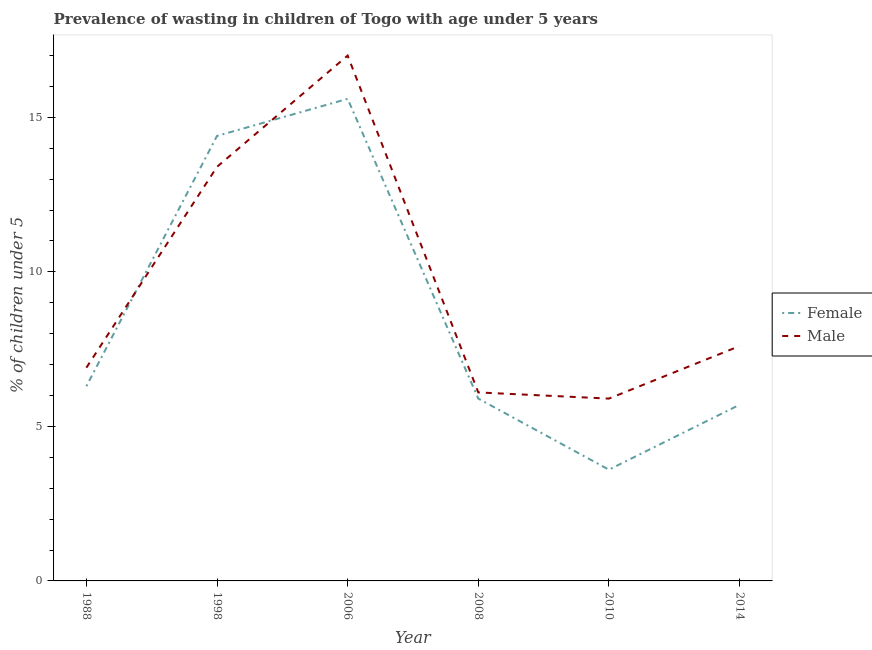How many different coloured lines are there?
Provide a short and direct response. 2. Is the number of lines equal to the number of legend labels?
Offer a very short reply. Yes. Across all years, what is the maximum percentage of undernourished male children?
Provide a succinct answer. 17. Across all years, what is the minimum percentage of undernourished male children?
Give a very brief answer. 5.9. In which year was the percentage of undernourished male children maximum?
Provide a short and direct response. 2006. What is the total percentage of undernourished female children in the graph?
Your response must be concise. 51.5. What is the difference between the percentage of undernourished female children in 1998 and that in 2010?
Provide a succinct answer. 10.8. What is the difference between the percentage of undernourished male children in 1998 and the percentage of undernourished female children in 2014?
Give a very brief answer. 7.7. What is the average percentage of undernourished female children per year?
Provide a short and direct response. 8.58. In the year 2010, what is the difference between the percentage of undernourished male children and percentage of undernourished female children?
Keep it short and to the point. 2.3. In how many years, is the percentage of undernourished male children greater than 12 %?
Your response must be concise. 2. What is the ratio of the percentage of undernourished male children in 2008 to that in 2010?
Give a very brief answer. 1.03. Is the difference between the percentage of undernourished female children in 1998 and 2010 greater than the difference between the percentage of undernourished male children in 1998 and 2010?
Make the answer very short. Yes. What is the difference between the highest and the second highest percentage of undernourished male children?
Your response must be concise. 3.6. What is the difference between the highest and the lowest percentage of undernourished female children?
Make the answer very short. 12. Is the percentage of undernourished male children strictly less than the percentage of undernourished female children over the years?
Provide a succinct answer. No. How many lines are there?
Your answer should be compact. 2. How many years are there in the graph?
Your answer should be very brief. 6. What is the difference between two consecutive major ticks on the Y-axis?
Offer a very short reply. 5. Are the values on the major ticks of Y-axis written in scientific E-notation?
Keep it short and to the point. No. Where does the legend appear in the graph?
Give a very brief answer. Center right. What is the title of the graph?
Keep it short and to the point. Prevalence of wasting in children of Togo with age under 5 years. What is the label or title of the X-axis?
Make the answer very short. Year. What is the label or title of the Y-axis?
Make the answer very short.  % of children under 5. What is the  % of children under 5 in Female in 1988?
Your response must be concise. 6.3. What is the  % of children under 5 in Male in 1988?
Keep it short and to the point. 6.9. What is the  % of children under 5 of Female in 1998?
Offer a very short reply. 14.4. What is the  % of children under 5 of Male in 1998?
Provide a succinct answer. 13.4. What is the  % of children under 5 of Female in 2006?
Keep it short and to the point. 15.6. What is the  % of children under 5 in Female in 2008?
Ensure brevity in your answer.  5.9. What is the  % of children under 5 of Male in 2008?
Offer a terse response. 6.1. What is the  % of children under 5 in Female in 2010?
Provide a succinct answer. 3.6. What is the  % of children under 5 of Male in 2010?
Provide a succinct answer. 5.9. What is the  % of children under 5 in Female in 2014?
Offer a terse response. 5.7. What is the  % of children under 5 in Male in 2014?
Your response must be concise. 7.6. Across all years, what is the maximum  % of children under 5 in Female?
Your response must be concise. 15.6. Across all years, what is the maximum  % of children under 5 in Male?
Give a very brief answer. 17. Across all years, what is the minimum  % of children under 5 in Female?
Make the answer very short. 3.6. Across all years, what is the minimum  % of children under 5 of Male?
Provide a succinct answer. 5.9. What is the total  % of children under 5 of Female in the graph?
Make the answer very short. 51.5. What is the total  % of children under 5 in Male in the graph?
Provide a succinct answer. 56.9. What is the difference between the  % of children under 5 of Male in 1988 and that in 1998?
Make the answer very short. -6.5. What is the difference between the  % of children under 5 of Male in 1988 and that in 2006?
Your answer should be very brief. -10.1. What is the difference between the  % of children under 5 in Female in 1988 and that in 2008?
Make the answer very short. 0.4. What is the difference between the  % of children under 5 in Male in 1988 and that in 2008?
Ensure brevity in your answer.  0.8. What is the difference between the  % of children under 5 of Female in 1988 and that in 2010?
Ensure brevity in your answer.  2.7. What is the difference between the  % of children under 5 in Male in 1988 and that in 2010?
Make the answer very short. 1. What is the difference between the  % of children under 5 of Female in 1988 and that in 2014?
Give a very brief answer. 0.6. What is the difference between the  % of children under 5 in Female in 1998 and that in 2006?
Offer a very short reply. -1.2. What is the difference between the  % of children under 5 of Male in 1998 and that in 2008?
Offer a terse response. 7.3. What is the difference between the  % of children under 5 in Male in 1998 and that in 2010?
Give a very brief answer. 7.5. What is the difference between the  % of children under 5 of Male in 1998 and that in 2014?
Make the answer very short. 5.8. What is the difference between the  % of children under 5 in Female in 2006 and that in 2008?
Your answer should be compact. 9.7. What is the difference between the  % of children under 5 in Female in 2006 and that in 2010?
Keep it short and to the point. 12. What is the difference between the  % of children under 5 in Female in 2006 and that in 2014?
Your answer should be compact. 9.9. What is the difference between the  % of children under 5 of Male in 2008 and that in 2010?
Keep it short and to the point. 0.2. What is the difference between the  % of children under 5 in Male in 2008 and that in 2014?
Your answer should be compact. -1.5. What is the difference between the  % of children under 5 of Female in 1988 and the  % of children under 5 of Male in 2008?
Provide a succinct answer. 0.2. What is the difference between the  % of children under 5 of Female in 1988 and the  % of children under 5 of Male in 2010?
Keep it short and to the point. 0.4. What is the difference between the  % of children under 5 of Female in 1988 and the  % of children under 5 of Male in 2014?
Offer a terse response. -1.3. What is the difference between the  % of children under 5 in Female in 1998 and the  % of children under 5 in Male in 2006?
Make the answer very short. -2.6. What is the difference between the  % of children under 5 of Female in 1998 and the  % of children under 5 of Male in 2010?
Provide a succinct answer. 8.5. What is the difference between the  % of children under 5 of Female in 1998 and the  % of children under 5 of Male in 2014?
Your answer should be very brief. 6.8. What is the difference between the  % of children under 5 of Female in 2006 and the  % of children under 5 of Male in 2014?
Make the answer very short. 8. What is the average  % of children under 5 of Female per year?
Offer a terse response. 8.58. What is the average  % of children under 5 of Male per year?
Your answer should be very brief. 9.48. In the year 1998, what is the difference between the  % of children under 5 in Female and  % of children under 5 in Male?
Make the answer very short. 1. In the year 2006, what is the difference between the  % of children under 5 of Female and  % of children under 5 of Male?
Make the answer very short. -1.4. In the year 2014, what is the difference between the  % of children under 5 in Female and  % of children under 5 in Male?
Keep it short and to the point. -1.9. What is the ratio of the  % of children under 5 in Female in 1988 to that in 1998?
Make the answer very short. 0.44. What is the ratio of the  % of children under 5 of Male in 1988 to that in 1998?
Keep it short and to the point. 0.51. What is the ratio of the  % of children under 5 of Female in 1988 to that in 2006?
Your answer should be very brief. 0.4. What is the ratio of the  % of children under 5 in Male in 1988 to that in 2006?
Ensure brevity in your answer.  0.41. What is the ratio of the  % of children under 5 in Female in 1988 to that in 2008?
Keep it short and to the point. 1.07. What is the ratio of the  % of children under 5 of Male in 1988 to that in 2008?
Your response must be concise. 1.13. What is the ratio of the  % of children under 5 of Male in 1988 to that in 2010?
Your answer should be compact. 1.17. What is the ratio of the  % of children under 5 of Female in 1988 to that in 2014?
Ensure brevity in your answer.  1.11. What is the ratio of the  % of children under 5 of Male in 1988 to that in 2014?
Your answer should be compact. 0.91. What is the ratio of the  % of children under 5 of Male in 1998 to that in 2006?
Your answer should be compact. 0.79. What is the ratio of the  % of children under 5 in Female in 1998 to that in 2008?
Your answer should be very brief. 2.44. What is the ratio of the  % of children under 5 in Male in 1998 to that in 2008?
Offer a terse response. 2.2. What is the ratio of the  % of children under 5 of Male in 1998 to that in 2010?
Offer a terse response. 2.27. What is the ratio of the  % of children under 5 in Female in 1998 to that in 2014?
Your answer should be very brief. 2.53. What is the ratio of the  % of children under 5 of Male in 1998 to that in 2014?
Keep it short and to the point. 1.76. What is the ratio of the  % of children under 5 of Female in 2006 to that in 2008?
Provide a short and direct response. 2.64. What is the ratio of the  % of children under 5 of Male in 2006 to that in 2008?
Make the answer very short. 2.79. What is the ratio of the  % of children under 5 in Female in 2006 to that in 2010?
Offer a very short reply. 4.33. What is the ratio of the  % of children under 5 of Male in 2006 to that in 2010?
Your answer should be very brief. 2.88. What is the ratio of the  % of children under 5 of Female in 2006 to that in 2014?
Keep it short and to the point. 2.74. What is the ratio of the  % of children under 5 of Male in 2006 to that in 2014?
Your answer should be very brief. 2.24. What is the ratio of the  % of children under 5 in Female in 2008 to that in 2010?
Give a very brief answer. 1.64. What is the ratio of the  % of children under 5 of Male in 2008 to that in 2010?
Ensure brevity in your answer.  1.03. What is the ratio of the  % of children under 5 in Female in 2008 to that in 2014?
Ensure brevity in your answer.  1.04. What is the ratio of the  % of children under 5 of Male in 2008 to that in 2014?
Your answer should be very brief. 0.8. What is the ratio of the  % of children under 5 in Female in 2010 to that in 2014?
Your answer should be very brief. 0.63. What is the ratio of the  % of children under 5 in Male in 2010 to that in 2014?
Provide a short and direct response. 0.78. What is the difference between the highest and the second highest  % of children under 5 of Male?
Offer a terse response. 3.6. What is the difference between the highest and the lowest  % of children under 5 in Female?
Ensure brevity in your answer.  12. What is the difference between the highest and the lowest  % of children under 5 of Male?
Your answer should be compact. 11.1. 